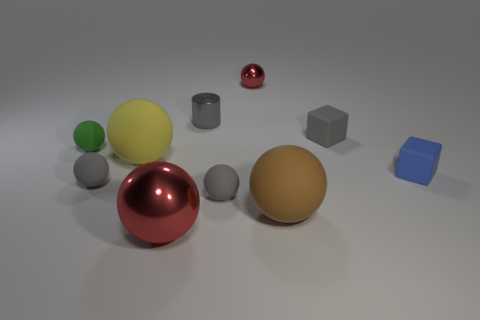The large metal ball has what color?
Ensure brevity in your answer.  Red. There is a matte block behind the blue thing; is it the same color as the cylinder?
Offer a terse response. Yes. There is a yellow matte object that is the same size as the brown rubber thing; what shape is it?
Your response must be concise. Sphere. The large brown rubber object has what shape?
Offer a very short reply. Sphere. Does the block that is in front of the tiny green thing have the same material as the green thing?
Make the answer very short. Yes. How big is the red ball behind the shiny sphere that is in front of the tiny red metal sphere?
Your response must be concise. Small. There is a small matte object that is to the right of the small metal cylinder and left of the big brown object; what is its color?
Give a very brief answer. Gray. There is a blue object that is the same size as the green thing; what material is it?
Your response must be concise. Rubber. How many other things are there of the same material as the tiny blue object?
Ensure brevity in your answer.  6. There is a shiny sphere that is behind the large red ball; is it the same color as the large object that is in front of the large brown object?
Provide a succinct answer. Yes. 